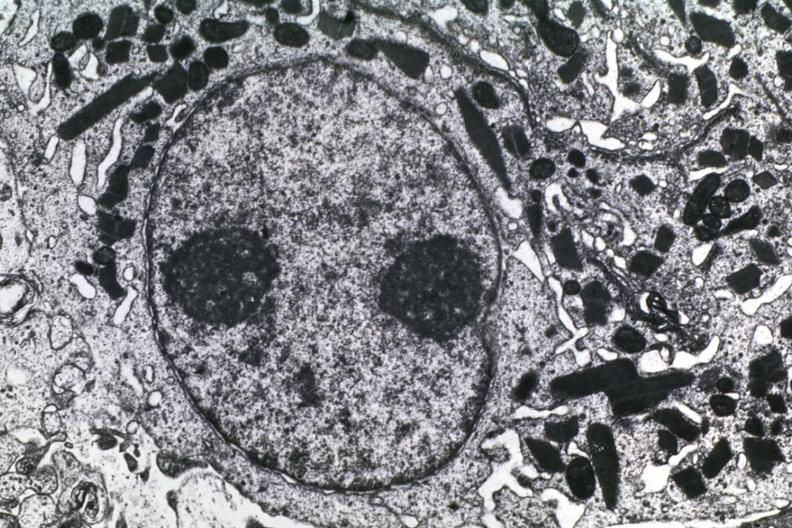s silver present?
Answer the question using a single word or phrase. No 